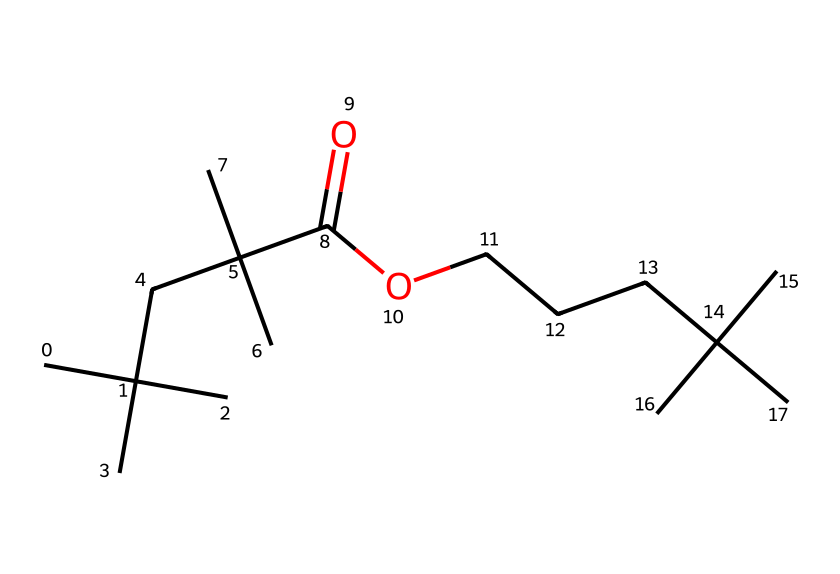how many carbon atoms are in the structure? In the SMILES representation, each 'C' indicates a carbon atom. By counting each 'C' in the given structure, there are a total of 17 carbon atoms.
Answer: 17 what is the functional group present in this chemical? The structure contains a carboxylic acid group, indicated by 'C(=O)O', which signifies the presence of a carbonyl (C=O) attached to a hydroxyl (-OH) group.
Answer: carboxylic acid how many branches does the carbon chain have? By analyzing the carbon chain in the SMILES, we can see that the branching occurs at several positions, specifically from the core carbon structures, indicating multiple branches. The structure has 6 branches.
Answer: 6 what type of detergent does this compound represent? Given the presence of a long carbon chain and a carboxylic acid functional group, this compound can be characterized as a surfactant, specifically a non-ionic or anionic detergent due to its molecular structure.
Answer: surfactant what impact does the length of the carbon chain have on its cleaning ability? Longer carbon chains tend to improve hydrophobic interactions while facilitating the removal of oily or greasy substances, enhancing the cleaning efficacy of the detergent. The presence of 17 carbon atoms can indicate good cleaning properties, especially against grease.
Answer: good cleaning properties 